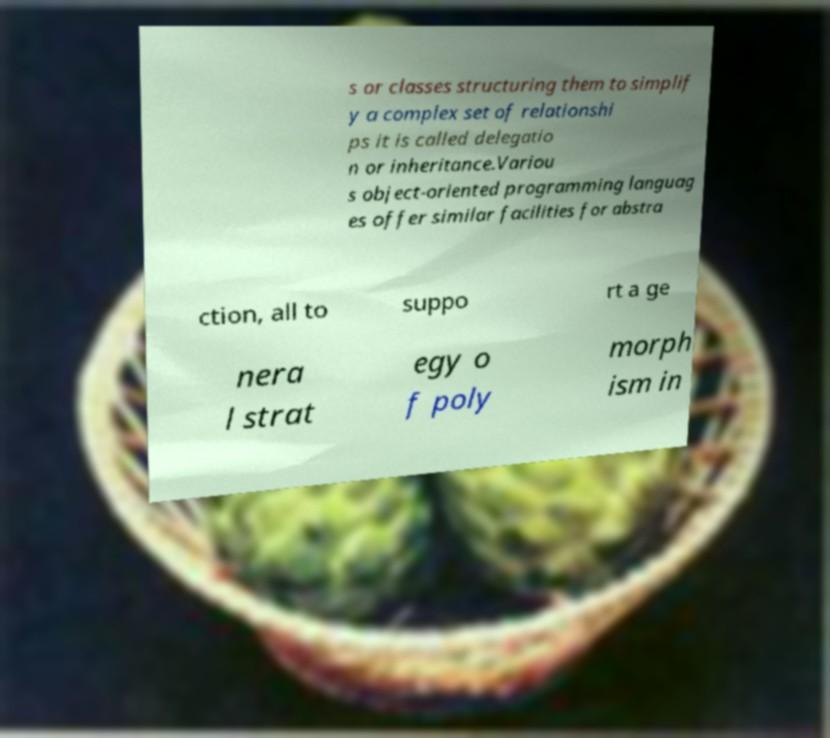For documentation purposes, I need the text within this image transcribed. Could you provide that? s or classes structuring them to simplif y a complex set of relationshi ps it is called delegatio n or inheritance.Variou s object-oriented programming languag es offer similar facilities for abstra ction, all to suppo rt a ge nera l strat egy o f poly morph ism in 